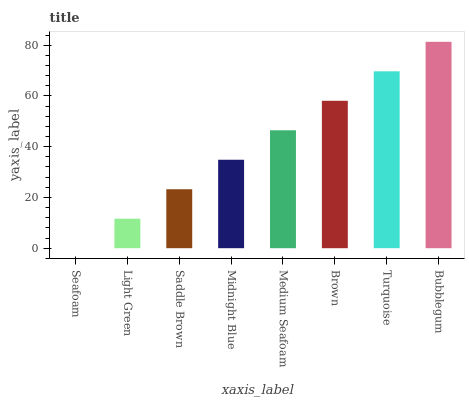Is Seafoam the minimum?
Answer yes or no. Yes. Is Bubblegum the maximum?
Answer yes or no. Yes. Is Light Green the minimum?
Answer yes or no. No. Is Light Green the maximum?
Answer yes or no. No. Is Light Green greater than Seafoam?
Answer yes or no. Yes. Is Seafoam less than Light Green?
Answer yes or no. Yes. Is Seafoam greater than Light Green?
Answer yes or no. No. Is Light Green less than Seafoam?
Answer yes or no. No. Is Medium Seafoam the high median?
Answer yes or no. Yes. Is Midnight Blue the low median?
Answer yes or no. Yes. Is Turquoise the high median?
Answer yes or no. No. Is Saddle Brown the low median?
Answer yes or no. No. 